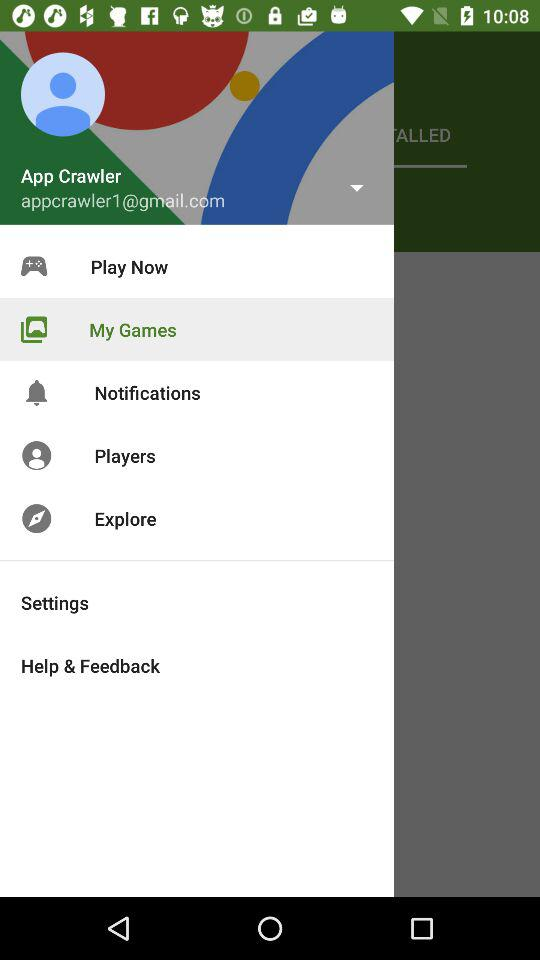What is the email address? The email address is appcrawler1@gmail.com. 